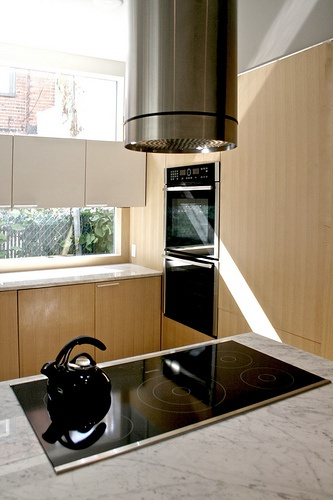Describe the objects in this image and their specific colors. I can see oven in white, black, gray, and darkgray tones and oven in white, black, gray, and olive tones in this image. 